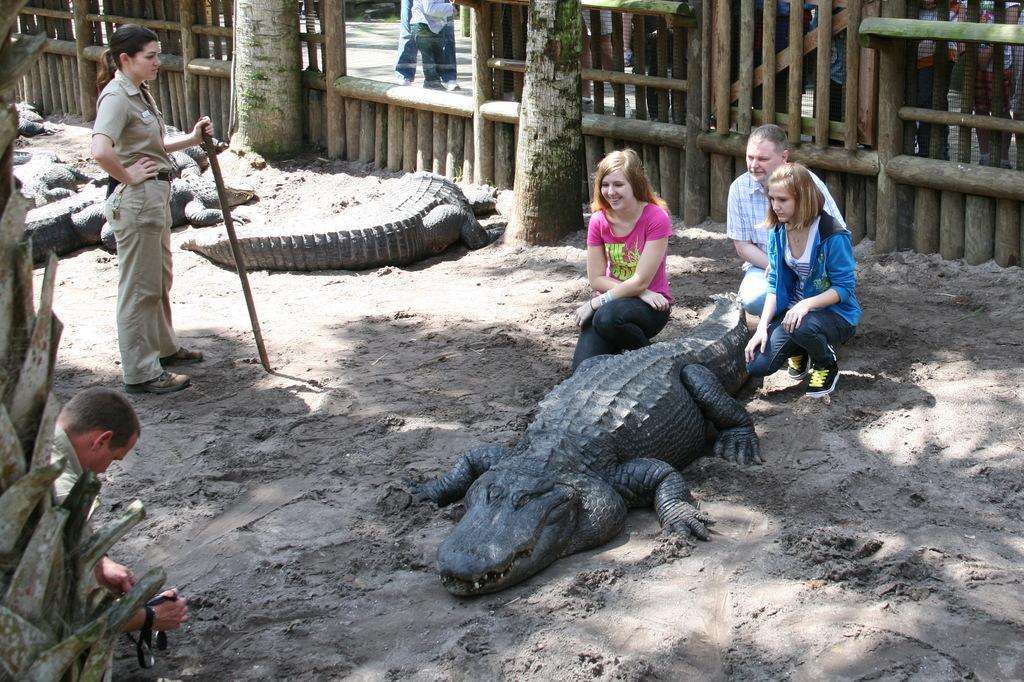Describe this image in one or two sentences. In this picture we can see some crocodiles are on the sand, few people are sitting beside and taking picture, one woman is standing and holding stick, around we can see wooden fencing. 